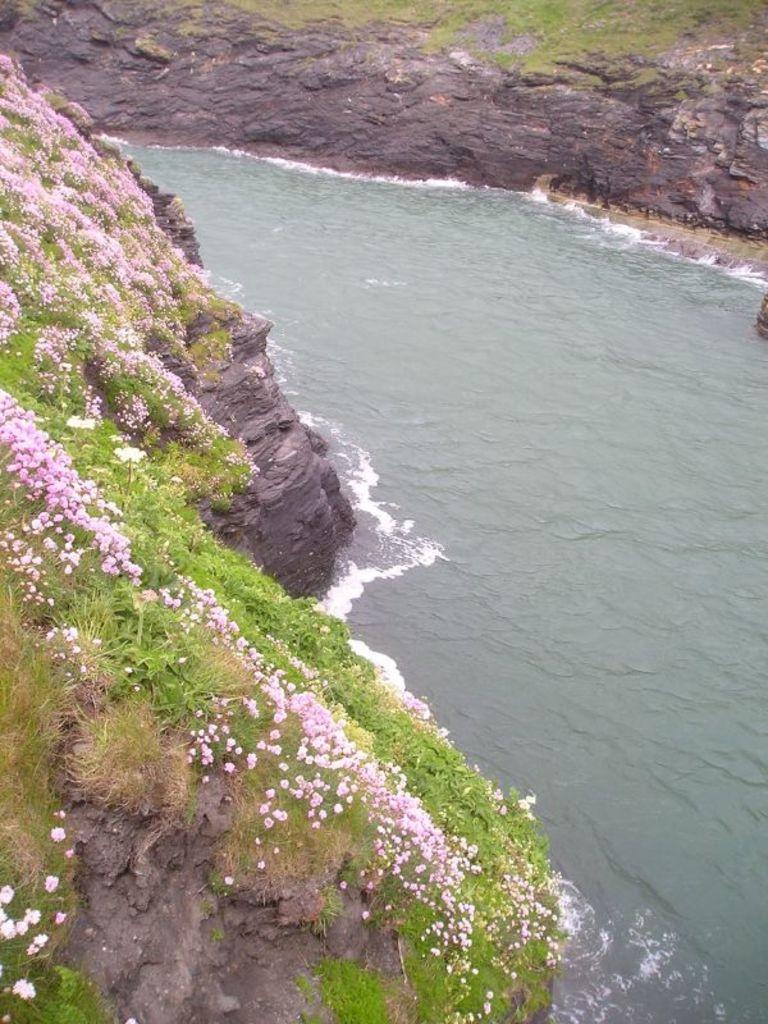Can you describe this image briefly? In the center of the image there is a river. On the left side of the image there are plants with the flowers on it. On the right side of the image there are rocks. 